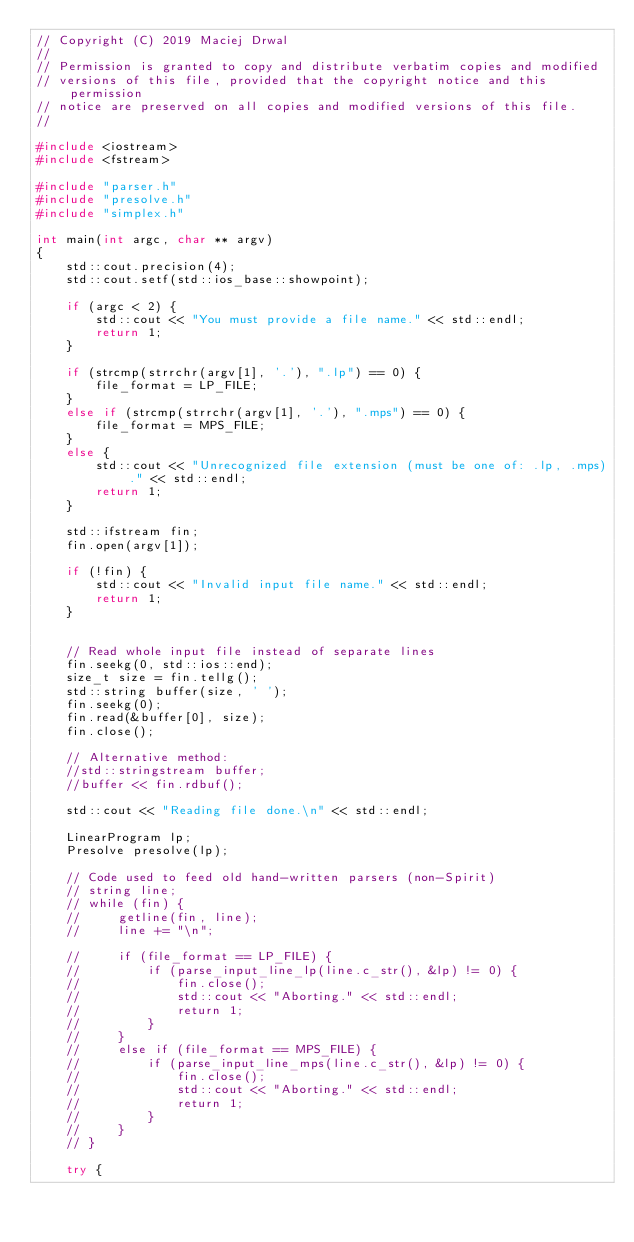<code> <loc_0><loc_0><loc_500><loc_500><_C++_>// Copyright (C) 2019 Maciej Drwal
// 
// Permission is granted to copy and distribute verbatim copies and modified
// versions of this file, provided that the copyright notice and this permission
// notice are preserved on all copies and modified versions of this file.
// 

#include <iostream>
#include <fstream>

#include "parser.h"
#include "presolve.h"
#include "simplex.h"

int main(int argc, char ** argv) 
{
    std::cout.precision(4);
    std::cout.setf(std::ios_base::showpoint);
    
    if (argc < 2) {
        std::cout << "You must provide a file name." << std::endl;
        return 1;
    }

    if (strcmp(strrchr(argv[1], '.'), ".lp") == 0) {
        file_format = LP_FILE;
    }
    else if (strcmp(strrchr(argv[1], '.'), ".mps") == 0) {
        file_format = MPS_FILE;
    }
    else {
        std::cout << "Unrecognized file extension (must be one of: .lp, .mps)." << std::endl;
        return 1;
    }
    
    std::ifstream fin;
    fin.open(argv[1]);
    
    if (!fin) {
        std::cout << "Invalid input file name." << std::endl;
        return 1;
    }


    // Read whole input file instead of separate lines
    fin.seekg(0, std::ios::end);
    size_t size = fin.tellg();
    std::string buffer(size, ' ');
    fin.seekg(0);
    fin.read(&buffer[0], size);
    fin.close();

    // Alternative method:
    //std::stringstream buffer;
    //buffer << fin.rdbuf();

    std::cout << "Reading file done.\n" << std::endl;

    LinearProgram lp;
    Presolve presolve(lp);

    // Code used to feed old hand-written parsers (non-Spirit)
    // string line;
    // while (fin) {        
    //     getline(fin, line);
    //     line += "\n";
        
    //     if (file_format == LP_FILE) {            
    //         if (parse_input_line_lp(line.c_str(), &lp) != 0) {
    //             fin.close();
    //             std::cout << "Aborting." << std::endl;
    //             return 1;
    //         }
    //     }
    //     else if (file_format == MPS_FILE) {
    //         if (parse_input_line_mps(line.c_str(), &lp) != 0) {
    //             fin.close();
    //             std::cout << "Aborting." << std::endl;
    //             return 1;
    //         }
    //     }
    // }

    try {</code> 